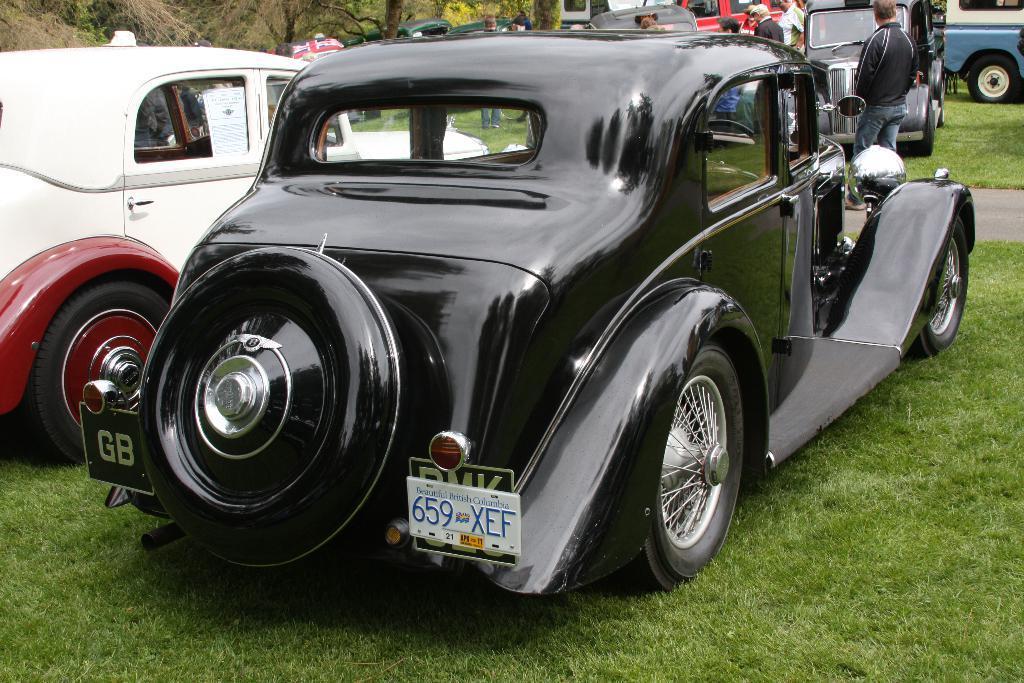Describe this image in one or two sentences. In this image we can see many cars, trees and few people. There is a grassy land and a road in the image. 